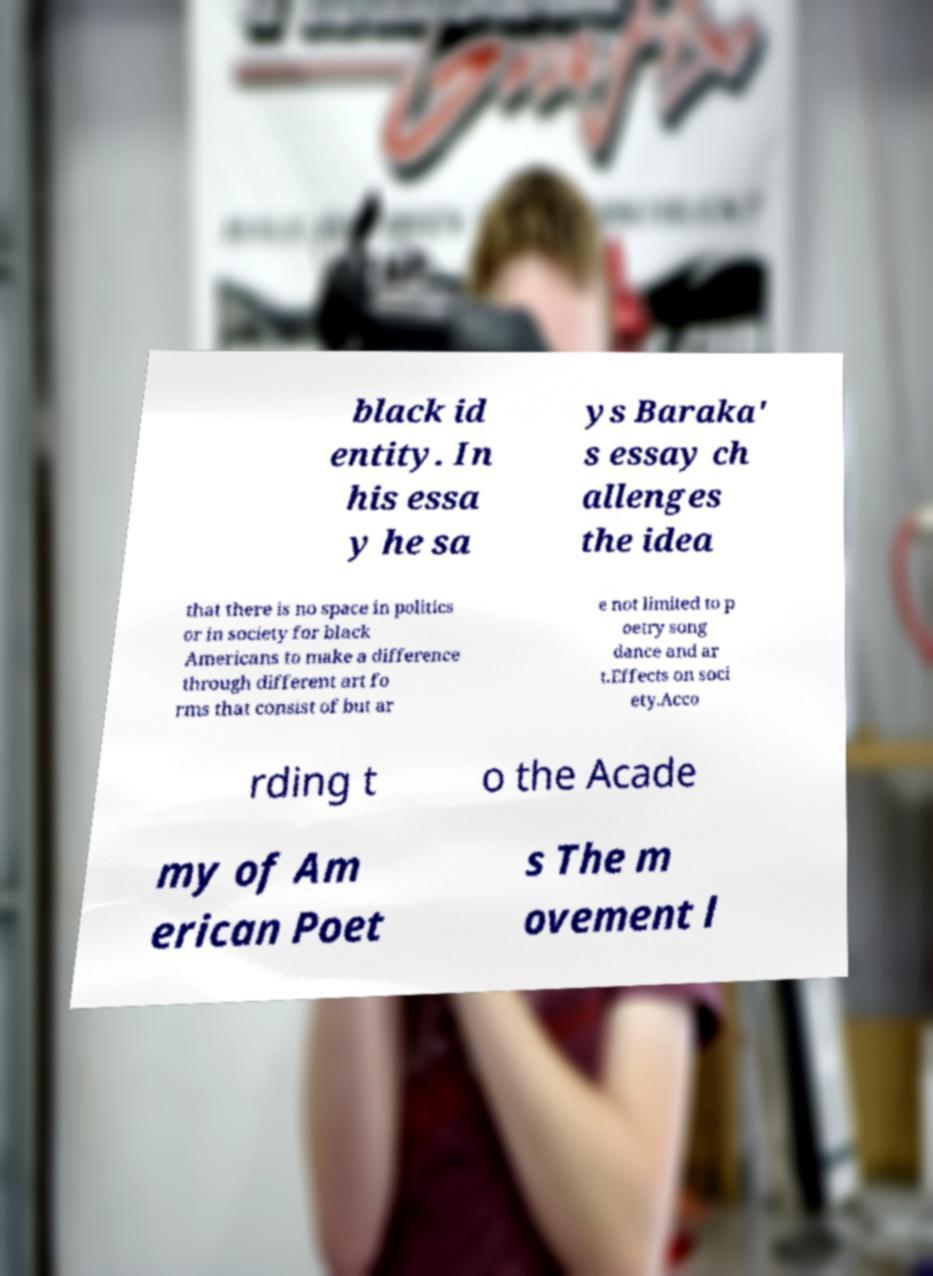I need the written content from this picture converted into text. Can you do that? black id entity. In his essa y he sa ys Baraka' s essay ch allenges the idea that there is no space in politics or in society for black Americans to make a difference through different art fo rms that consist of but ar e not limited to p oetry song dance and ar t.Effects on soci ety.Acco rding t o the Acade my of Am erican Poet s The m ovement l 